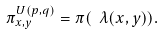Convert formula to latex. <formula><loc_0><loc_0><loc_500><loc_500>\pi _ { x , y } ^ { U ( p , q ) } = \pi ( \ \lambda ( x , y ) ) .</formula> 